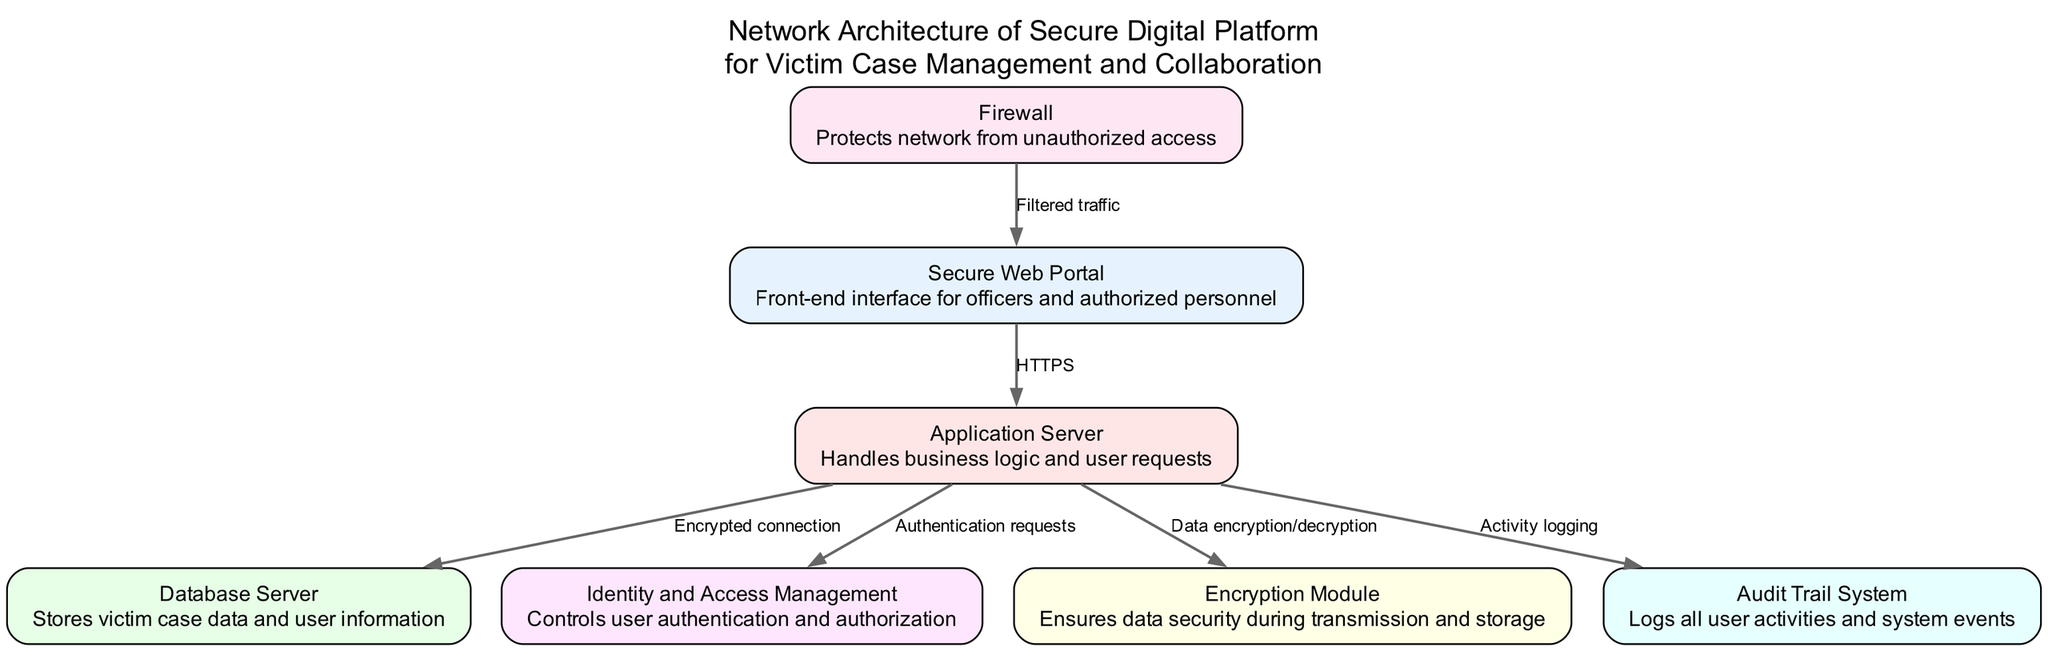What is the name of the front-end interface? Referring to the diagram, the node labeled "Secure Web Portal" is identified as the front-end interface for officers and authorized personnel.
Answer: Secure Web Portal How many nodes are present in the diagram? By counting the nodes listed in the data section, there are a total of seven unique nodes representing different components of the system.
Answer: 7 What type of connection is used between the Secure Web Portal and the Application Server? The diagram specifies an "HTTPS" connection between the Secure Web Portal and the Application Server, indicating a secure communication protocol.
Answer: HTTPS Which module ensures data security during transmission? The "Encryption Module" is specifically mentioned in the diagram as responsible for ensuring data security during both transmission and storage.
Answer: Encryption Module What is the purpose of the Audit Trail System? The Audit Trail System is described in the diagram as a component that logs all user activities and system events, contributing to accountability and tracking.
Answer: Logs activities What type of access does the Firewall provide to the Secure Web Portal? According to the diagram, the Firewall provides "Filtered traffic" to the Secure Web Portal, denoting that it screens incoming network traffic.
Answer: Filtered traffic What is the direct connection between the Application Server and the Database Server? The diagram states there is an "Encrypted connection" facilitating the direct communication between the Application Server and the Database Server.
Answer: Encrypted connection How many edges are connecting the nodes in the diagram? By analyzing the edges provided, there are a total of six connections linking the various nodes within the network architecture.
Answer: 6 What does the Identity and Access Management control? The Identity and Access Management component's role is to control "user authentication and authorization," as highlighted in the diagram.
Answer: User authentication What is the relationship between the Application Server and the Encryption Module? The diagram shows a direct relationship where the Application Server sends requests for "Data encryption/decryption" to the Encryption Module, indicating a functionally interconnected workflow.
Answer: Data encryption/decryption 